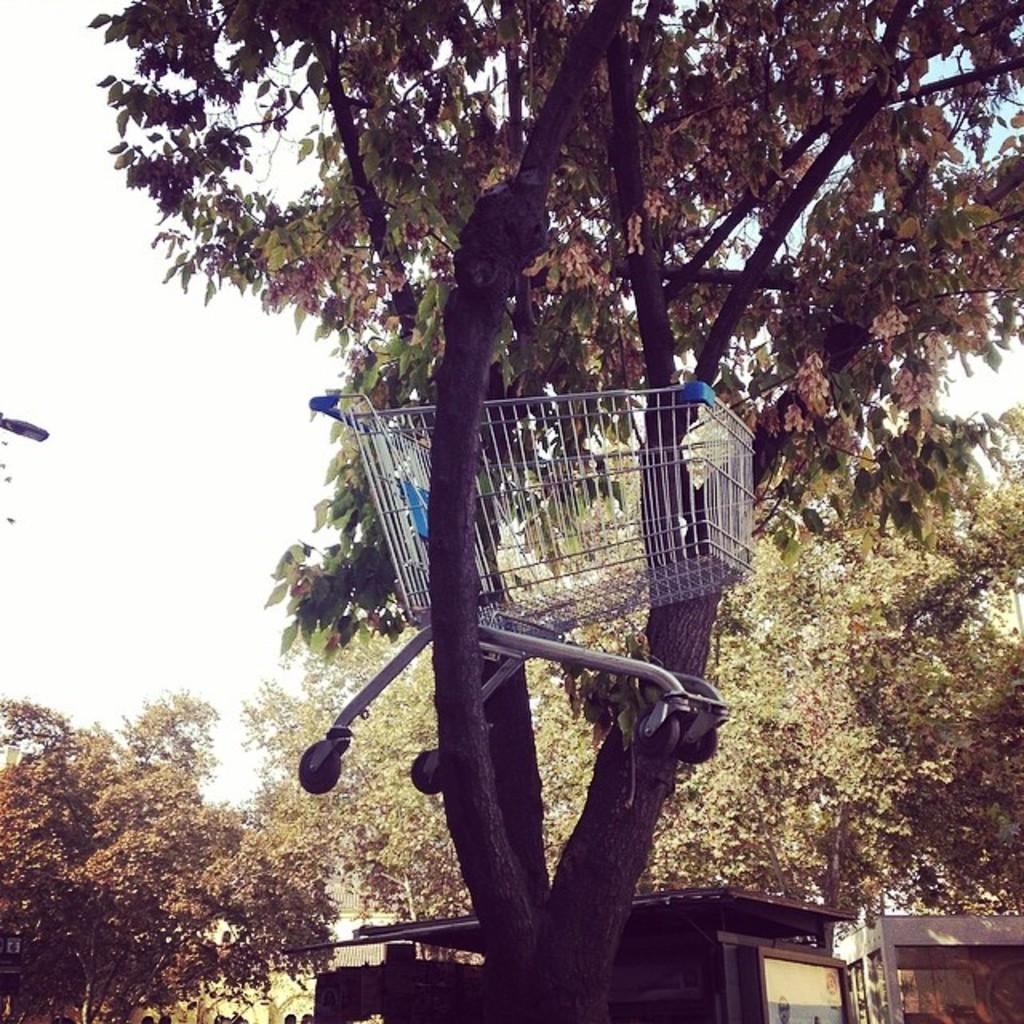What object is featured in the image that is typically used for transporting items? There is a trolley in the image. Where is the trolley located? The trolley is on a tree. What can be seen in the background of the image? There are trees, buildings, and the sky visible in the background of the image. What is the temperature of the lake in the image? There is no lake present in the image, so it is not possible to determine the temperature. 